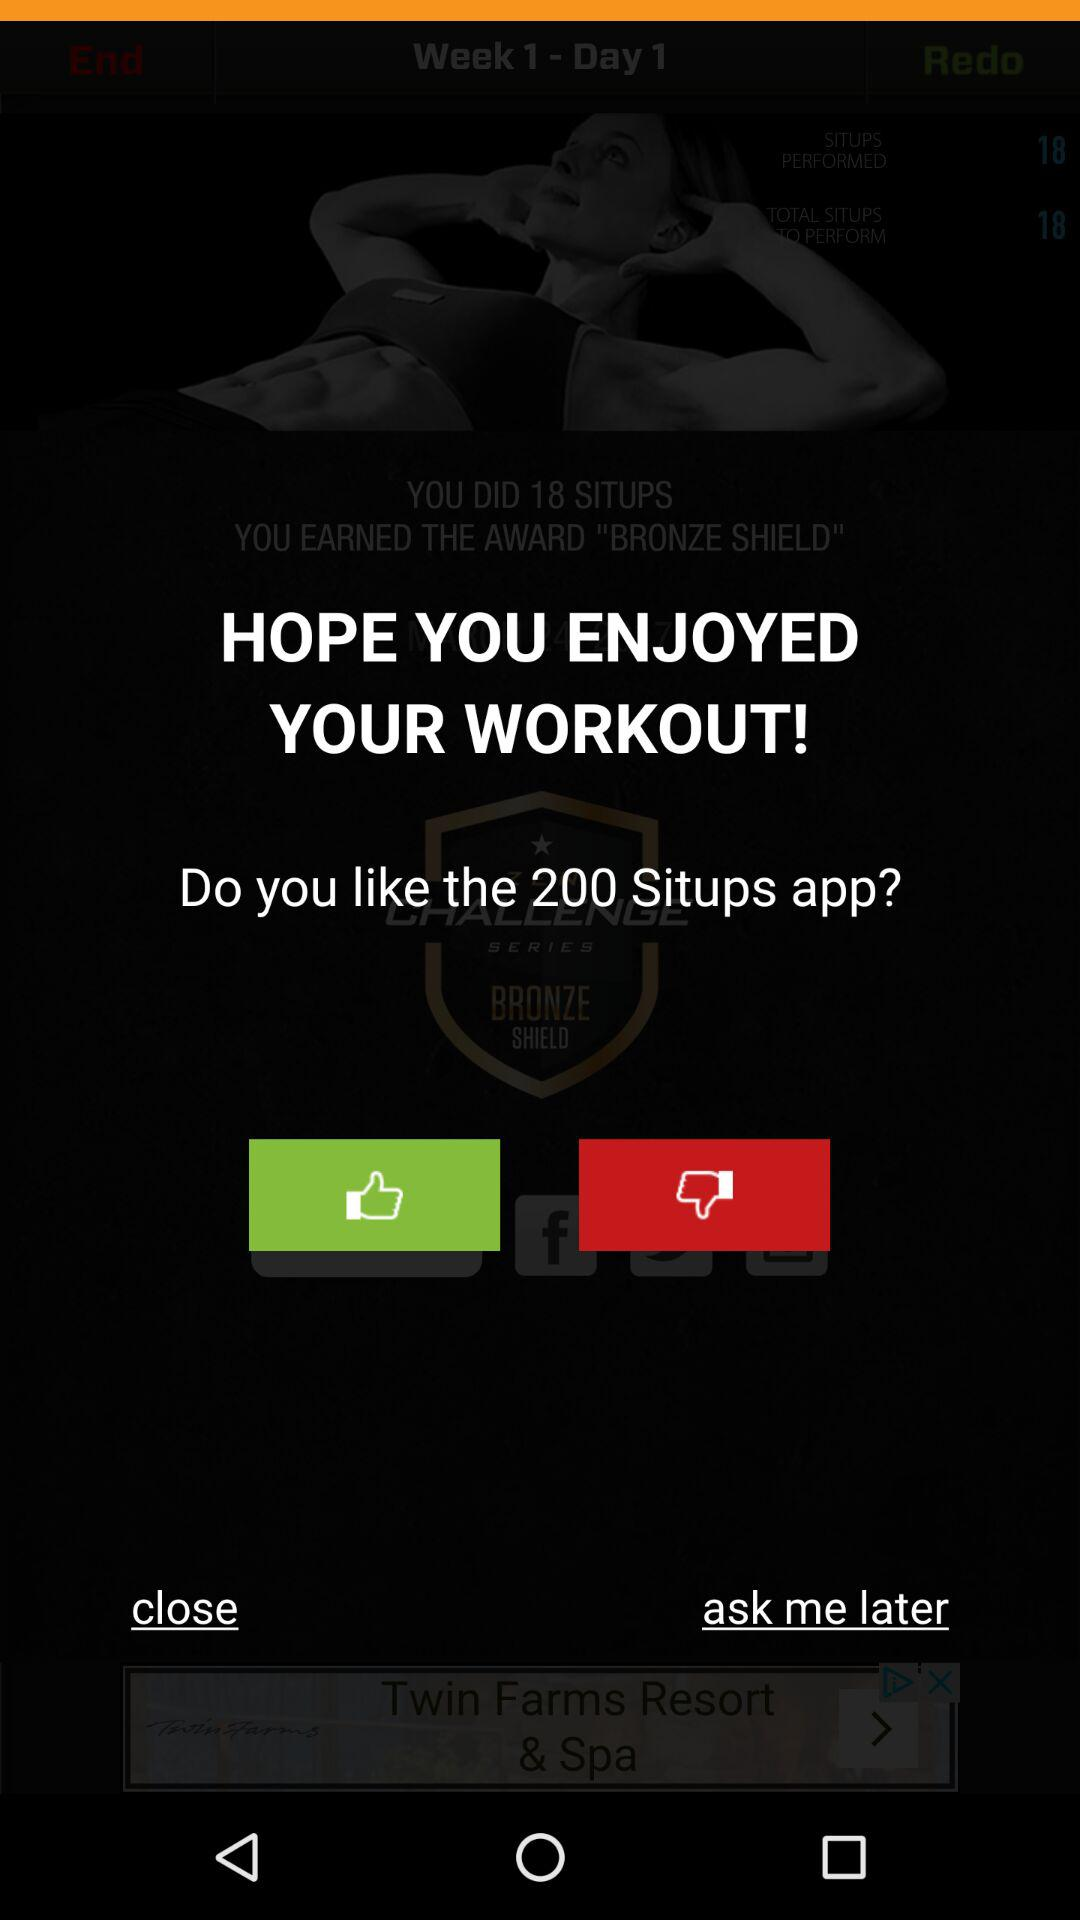How many sit-ups were done on May 7, 2013?
When the provided information is insufficient, respond with <no answer>. <no answer> 